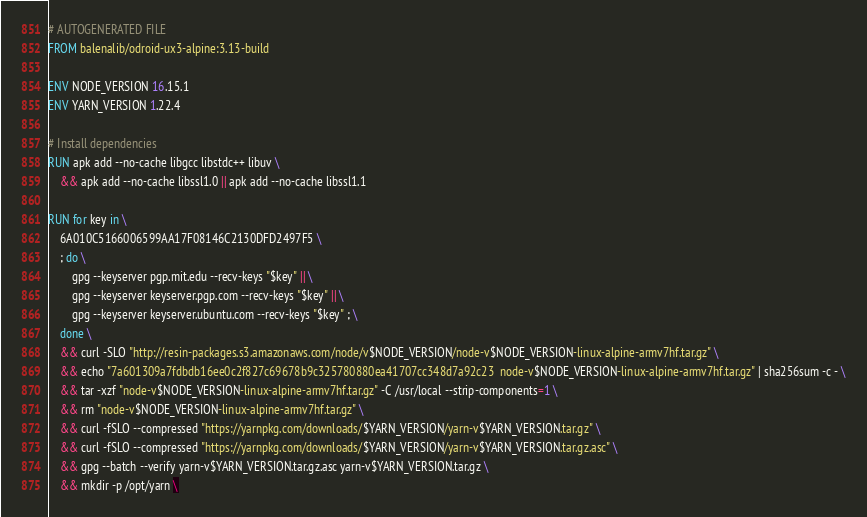<code> <loc_0><loc_0><loc_500><loc_500><_Dockerfile_># AUTOGENERATED FILE
FROM balenalib/odroid-ux3-alpine:3.13-build

ENV NODE_VERSION 16.15.1
ENV YARN_VERSION 1.22.4

# Install dependencies
RUN apk add --no-cache libgcc libstdc++ libuv \
	&& apk add --no-cache libssl1.0 || apk add --no-cache libssl1.1

RUN for key in \
	6A010C5166006599AA17F08146C2130DFD2497F5 \
	; do \
		gpg --keyserver pgp.mit.edu --recv-keys "$key" || \
		gpg --keyserver keyserver.pgp.com --recv-keys "$key" || \
		gpg --keyserver keyserver.ubuntu.com --recv-keys "$key" ; \
	done \
	&& curl -SLO "http://resin-packages.s3.amazonaws.com/node/v$NODE_VERSION/node-v$NODE_VERSION-linux-alpine-armv7hf.tar.gz" \
	&& echo "7a601309a7fdbdb16ee0c2f827c69678b9c325780880ea41707cc348d7a92c23  node-v$NODE_VERSION-linux-alpine-armv7hf.tar.gz" | sha256sum -c - \
	&& tar -xzf "node-v$NODE_VERSION-linux-alpine-armv7hf.tar.gz" -C /usr/local --strip-components=1 \
	&& rm "node-v$NODE_VERSION-linux-alpine-armv7hf.tar.gz" \
	&& curl -fSLO --compressed "https://yarnpkg.com/downloads/$YARN_VERSION/yarn-v$YARN_VERSION.tar.gz" \
	&& curl -fSLO --compressed "https://yarnpkg.com/downloads/$YARN_VERSION/yarn-v$YARN_VERSION.tar.gz.asc" \
	&& gpg --batch --verify yarn-v$YARN_VERSION.tar.gz.asc yarn-v$YARN_VERSION.tar.gz \
	&& mkdir -p /opt/yarn \</code> 